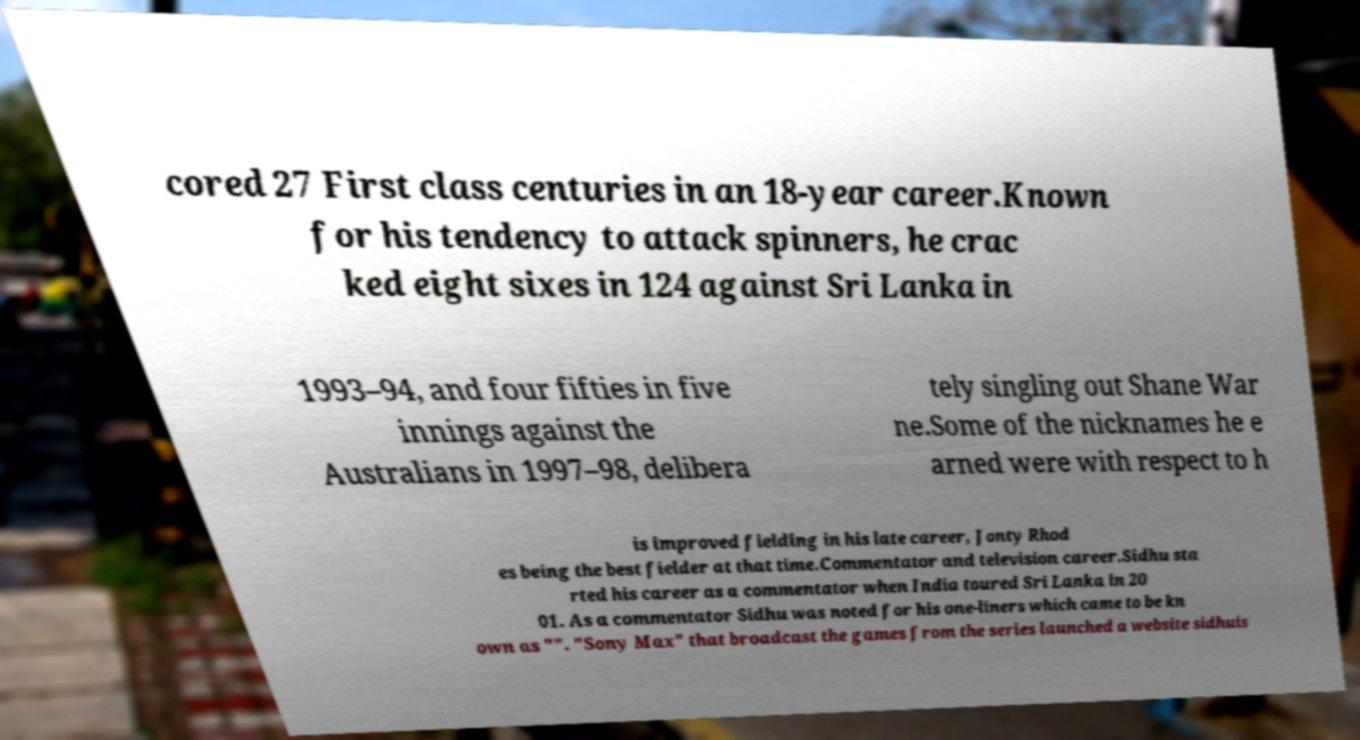I need the written content from this picture converted into text. Can you do that? cored 27 First class centuries in an 18-year career.Known for his tendency to attack spinners, he crac ked eight sixes in 124 against Sri Lanka in 1993–94, and four fifties in five innings against the Australians in 1997–98, delibera tely singling out Shane War ne.Some of the nicknames he e arned were with respect to h is improved fielding in his late career, Jonty Rhod es being the best fielder at that time.Commentator and television career.Sidhu sta rted his career as a commentator when India toured Sri Lanka in 20 01. As a commentator Sidhu was noted for his one-liners which came to be kn own as "". "Sony Max" that broadcast the games from the series launched a website sidhuis 